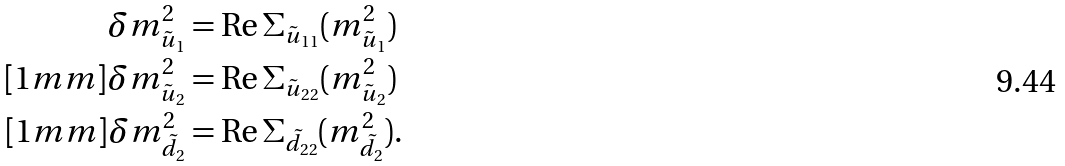<formula> <loc_0><loc_0><loc_500><loc_500>\delta m _ { \tilde { u } _ { 1 } } ^ { 2 } & = \text {Re} \, \Sigma _ { \tilde { u } _ { 1 1 } } ( m _ { { \tilde { u } } _ { 1 } } ^ { 2 } ) \\ [ 1 m m ] \delta m _ { \tilde { u } _ { 2 } } ^ { 2 } & = \text {Re} \, \Sigma _ { \tilde { u } _ { 2 2 } } ( m _ { { \tilde { u } } _ { 2 } } ^ { 2 } ) \\ [ 1 m m ] \delta m _ { \tilde { d } _ { 2 } } ^ { 2 } & = \text {Re} \, \Sigma _ { \tilde { d } _ { 2 2 } } ( m _ { { \tilde { d } } _ { 2 } } ^ { 2 } ) .</formula> 